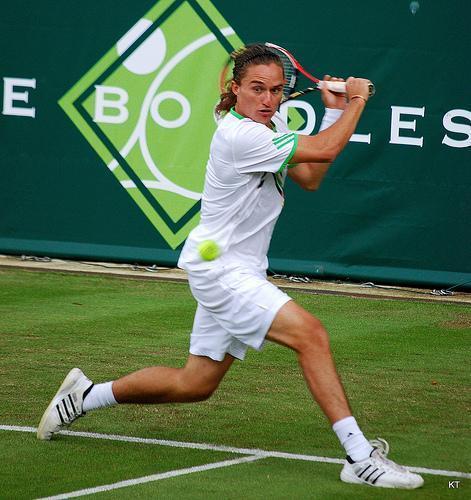How many tennis players are visible?
Give a very brief answer. 1. 